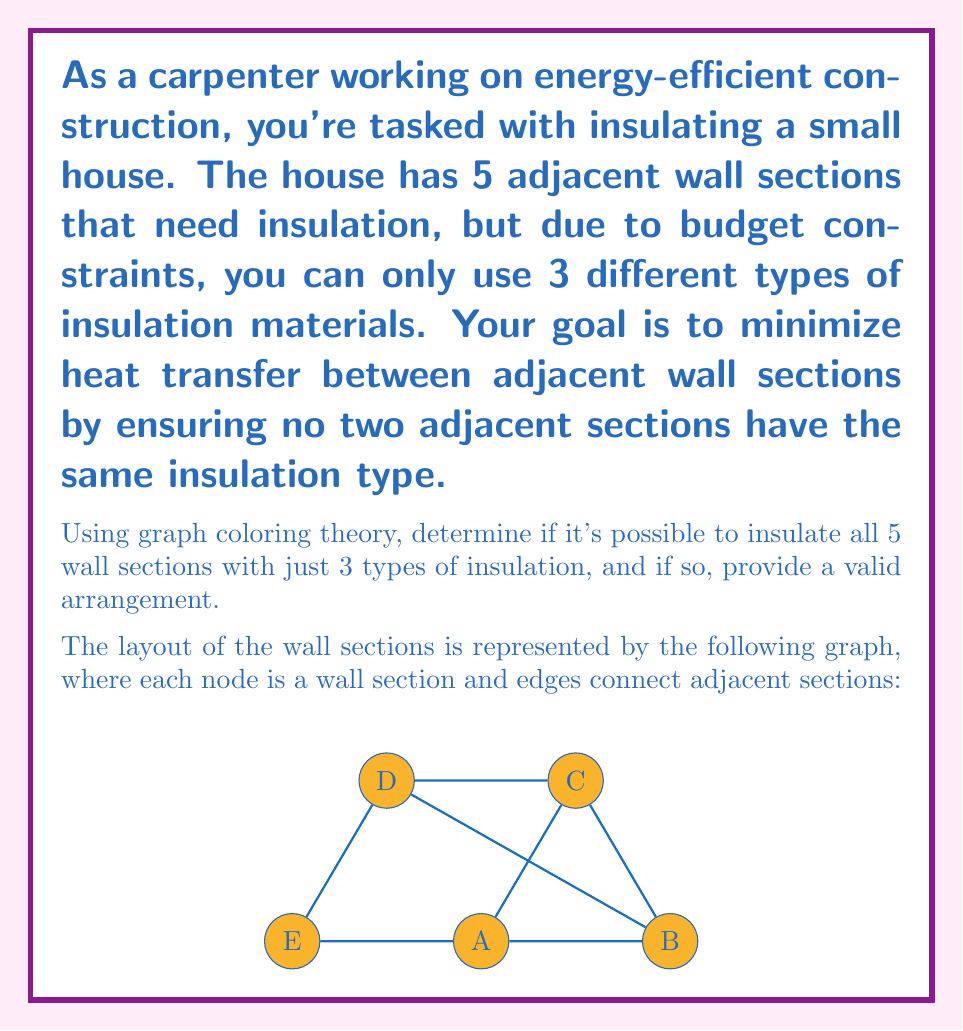Can you solve this math problem? To solve this problem, we'll use graph coloring theory. Here's a step-by-step approach:

1) First, we need to understand what the problem is asking:
   - We have 5 wall sections (nodes in the graph)
   - We have 3 types of insulation (colors)
   - Adjacent wall sections must have different insulation types (adjacent nodes must have different colors)

2) This is a classic graph coloring problem. We need to determine if the graph is 3-colorable.

3) Let's try to color the graph with 3 colors:
   - Start with node A and assign it color 1
   - Node B must be different, so assign it color 2
   - Node C is adjacent to both A and B, so it must be color 3
   - Node D is adjacent to B and C, so it can be color 1
   - Node E is adjacent to A and D, so it can be color 2

4) Check if this coloring is valid:
   - A (1) is adjacent to B (2), C (3), and E (2) - Valid
   - B (2) is adjacent to A (1), C (3), and D (1) - Valid
   - C (3) is adjacent to A (1), B (2), and D (1) - Valid
   - D (1) is adjacent to B (2), C (3), and E (2) - Valid
   - E (2) is adjacent to A (1) and D (1) - Valid

5) We've found a valid 3-coloring for the graph, which means it's possible to insulate all 5 wall sections with just 3 types of insulation.

6) The arrangement can be:
   - Wall sections A and D: Insulation type 1
   - Wall sections B and E: Insulation type 2
   - Wall section C: Insulation type 3
Answer: Yes, possible. Arrangement: A,D (type 1); B,E (type 2); C (type 3). 